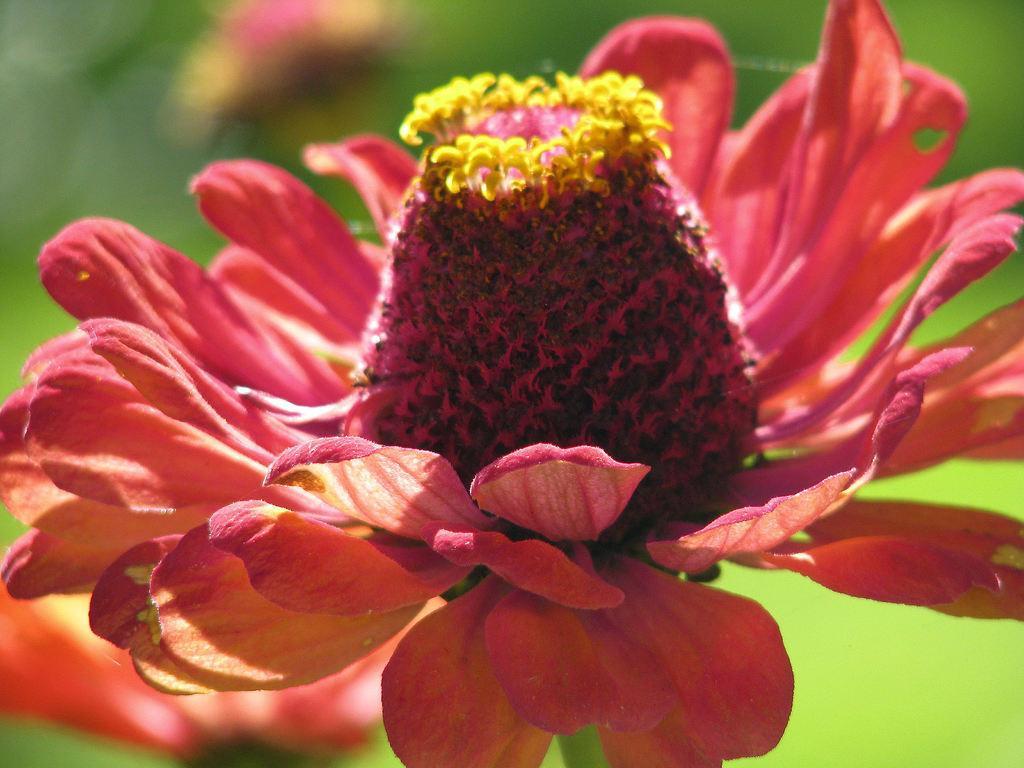What is the main subject of the image? The main subject of the image is a flower. Can you describe the flower's center? The flower has pollen grains in its center. How would you describe the background of the image? The background of the image is blurry. What type of structure is being advertised in the background of the image? There is no structure or advertisement present in the image; it only features a flower with a blurry background. 